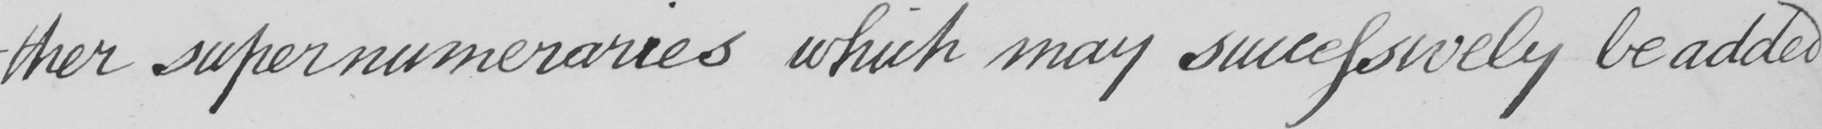What text is written in this handwritten line? -ther supernumeraries which may successively be added 